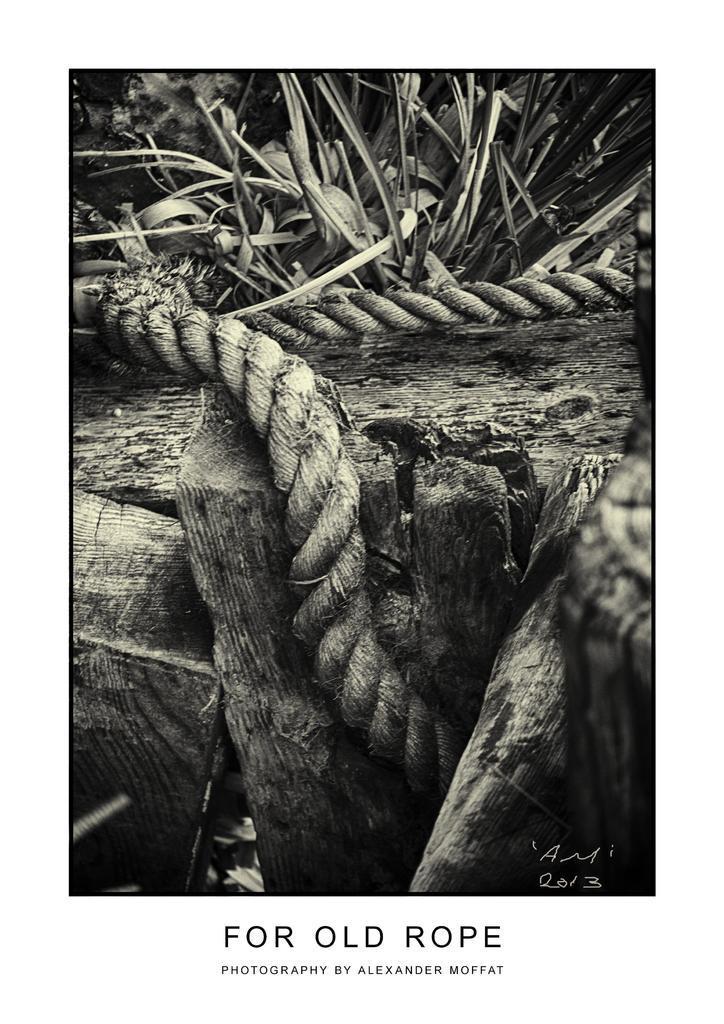How would you summarize this image in a sentence or two? This is a black and white image. In this there are ropes, wooden logs. In the back there is a plant. And something is written below the image. 